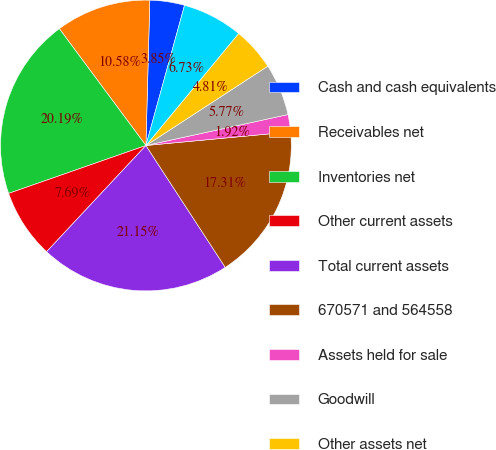Convert chart. <chart><loc_0><loc_0><loc_500><loc_500><pie_chart><fcel>Cash and cash equivalents<fcel>Receivables net<fcel>Inventories net<fcel>Other current assets<fcel>Total current assets<fcel>670571 and 564558<fcel>Assets held for sale<fcel>Goodwill<fcel>Other assets net<fcel>Bank overdrafts<nl><fcel>3.85%<fcel>10.58%<fcel>20.19%<fcel>7.69%<fcel>21.15%<fcel>17.31%<fcel>1.92%<fcel>5.77%<fcel>4.81%<fcel>6.73%<nl></chart> 